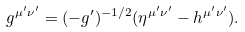Convert formula to latex. <formula><loc_0><loc_0><loc_500><loc_500>g ^ { \mu ^ { \prime } \nu ^ { \prime } } = ( - g ^ { \prime } ) ^ { - 1 / 2 } ( \eta ^ { \mu ^ { \prime } \nu ^ { \prime } } - h ^ { \mu ^ { \prime } \nu ^ { \prime } } ) .</formula> 